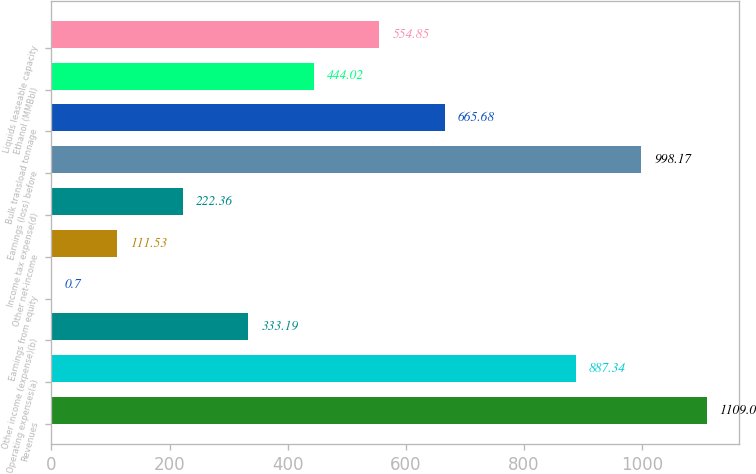<chart> <loc_0><loc_0><loc_500><loc_500><bar_chart><fcel>Revenues<fcel>Operating expenses(a)<fcel>Other income (expense)(b)<fcel>Earnings from equity<fcel>Other net-income<fcel>Income tax expense(d)<fcel>Earnings (loss) before<fcel>Bulk transload tonnage<fcel>Ethanol (MMBbl)<fcel>Liquids leaseable capacity<nl><fcel>1109<fcel>887.34<fcel>333.19<fcel>0.7<fcel>111.53<fcel>222.36<fcel>998.17<fcel>665.68<fcel>444.02<fcel>554.85<nl></chart> 